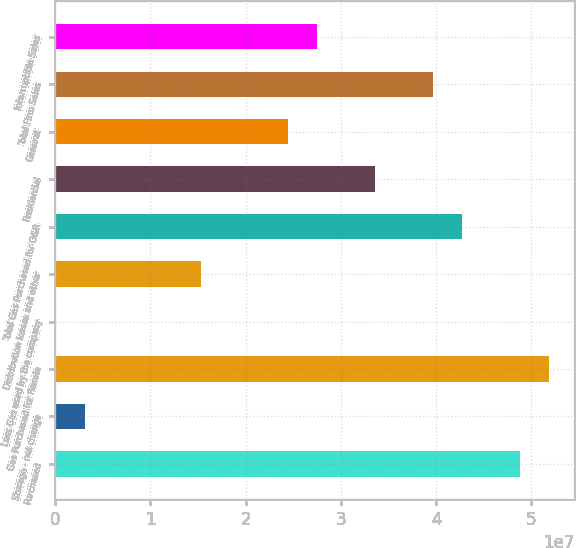Convert chart. <chart><loc_0><loc_0><loc_500><loc_500><bar_chart><fcel>Purchased<fcel>Storage - net change<fcel>Gas Purchased for Resale<fcel>Less Gas used by the company<fcel>Distribution losses and other<fcel>Total Gas Purchased for O&R<fcel>Residential<fcel>General<fcel>Total Firm Sales<fcel>Interruptible Sales<nl><fcel>4.88566e+07<fcel>3.09892e+06<fcel>5.19071e+07<fcel>48410<fcel>1.5301e+07<fcel>4.27555e+07<fcel>3.3604e+07<fcel>2.44525e+07<fcel>3.9705e+07<fcel>2.7503e+07<nl></chart> 